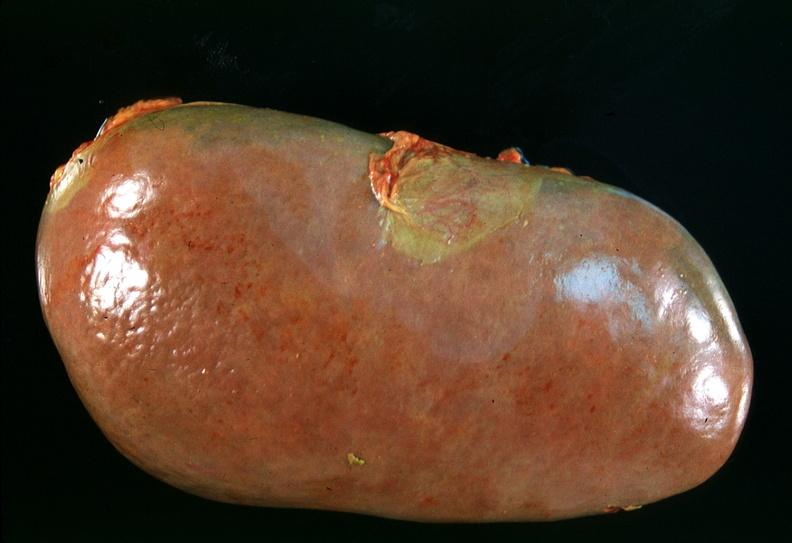where is this?
Answer the question using a single word or phrase. Urinary 